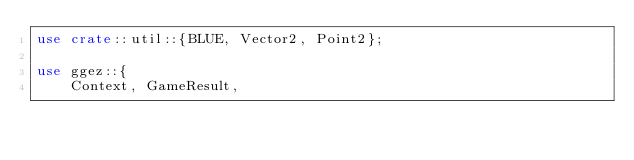Convert code to text. <code><loc_0><loc_0><loc_500><loc_500><_Rust_>use crate::util::{BLUE, Vector2, Point2};

use ggez::{
    Context, GameResult,</code> 